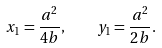Convert formula to latex. <formula><loc_0><loc_0><loc_500><loc_500>x _ { 1 } = \frac { a ^ { 2 } } { 4 b } , \quad y _ { 1 } = \frac { a ^ { 2 } } { 2 b } .</formula> 